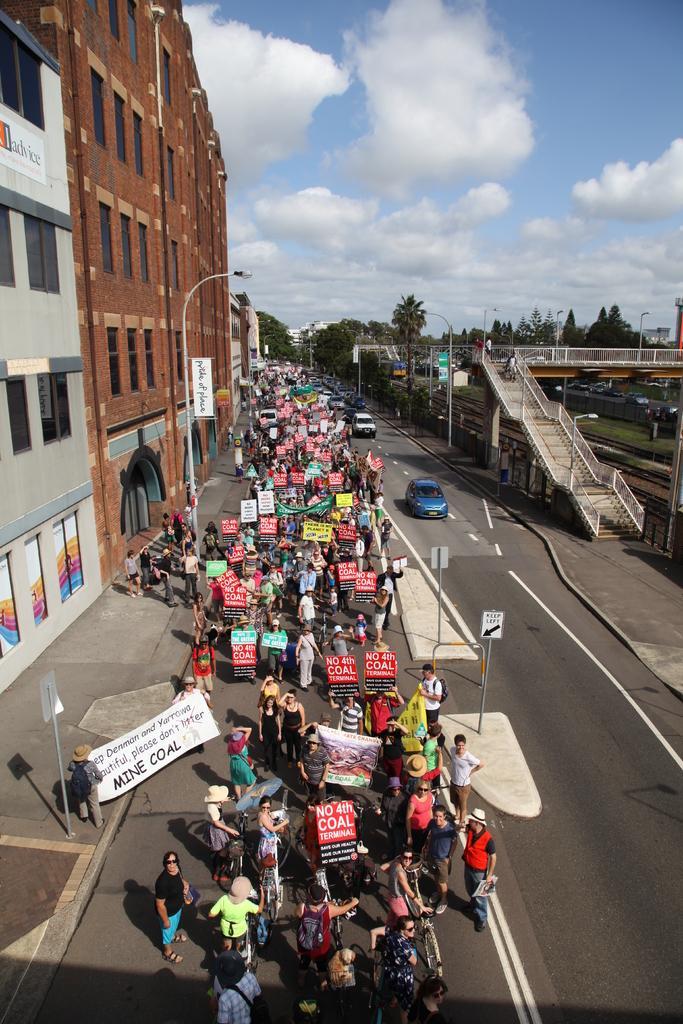Please provide a concise description of this image. In this picture we can see vehicles and people on the road. We have buildings on the left side and on the right side, we can see trees and grass. The sky is blue. 